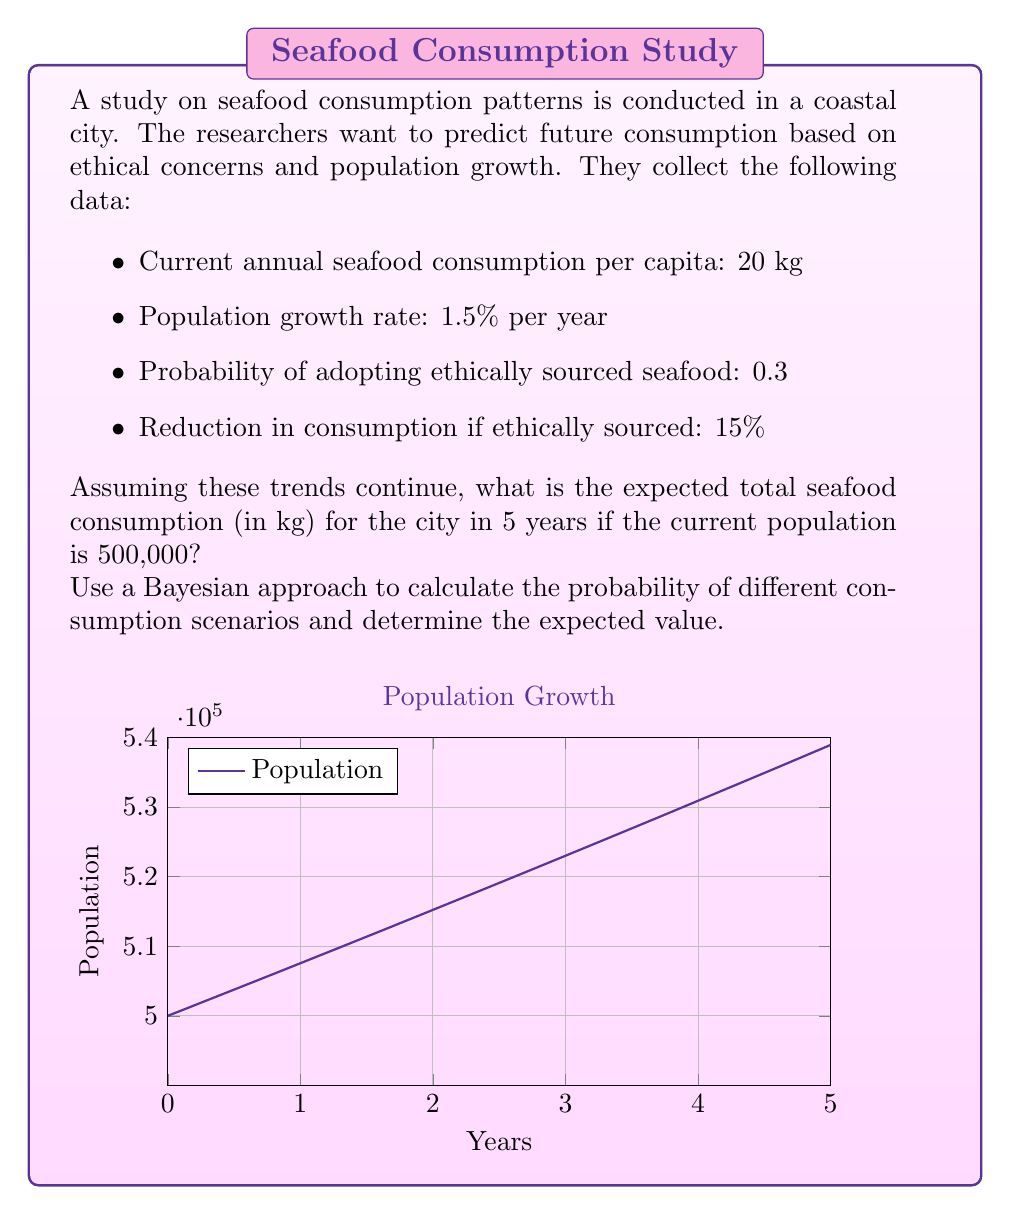Can you solve this math problem? Let's approach this step-by-step using Bayesian reasoning:

1) First, calculate the population after 5 years:
   $P_5 = 500,000 \cdot (1 + 0.015)^5 = 538,933.77$

2) Without ethical concerns, the consumption would be:
   $C_0 = 538,933.77 \cdot 20 = 10,778,675.4$ kg

3) Now, let's consider two scenarios:
   A: People adopt ethical sourcing (probability 0.3)
   B: People don't adopt ethical sourcing (probability 0.7)

4) If ethical sourcing is adopted, consumption reduces by 15%:
   $C_A = 10,778,675.4 \cdot (1 - 0.15) = 9,161,874.09$ kg

5) Expected consumption using Bayesian probability:
   $E(C) = P(A) \cdot C_A + P(B) \cdot C_0$
   $E(C) = 0.3 \cdot 9,161,874.09 + 0.7 \cdot 10,778,675.4$
   $E(C) = 2,748,562.23 + 7,545,072.78$
   $E(C) = 10,293,635.01$ kg

Therefore, the expected total seafood consumption in 5 years is approximately 10,293,635 kg.
Answer: 10,293,635 kg 